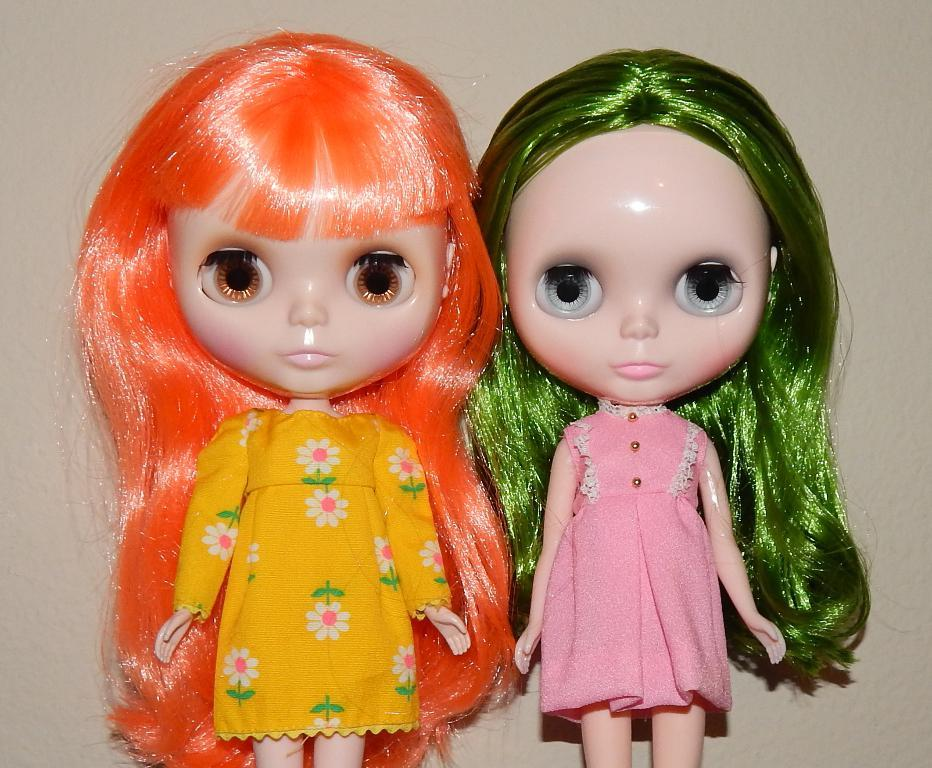How many dolls are present in the image? There are two dolls in the image. What position are the dolls in? The dolls are standing. What can be seen in the background of the image? There is a wall in the background of the image. Can you see any quartz rocks on the hill in the image? There is no hill or quartz rocks present in the image; it features two dolls standing in front of a wall. 